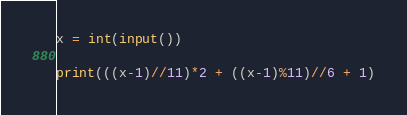<code> <loc_0><loc_0><loc_500><loc_500><_Python_>x = int(input())

print(((x-1)//11)*2 + ((x-1)%11)//6 + 1)
</code> 